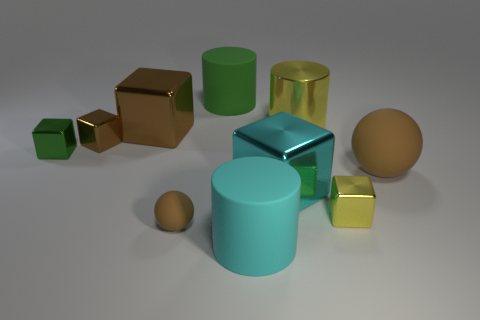Subtract all green shiny cubes. How many cubes are left? 4 Subtract all gray cubes. Subtract all brown spheres. How many cubes are left? 5 Subtract all spheres. How many objects are left? 8 Add 6 small metallic blocks. How many small metallic blocks are left? 9 Add 1 large yellow metal balls. How many large yellow metal balls exist? 1 Subtract 0 red blocks. How many objects are left? 10 Subtract all big blue things. Subtract all big yellow cylinders. How many objects are left? 9 